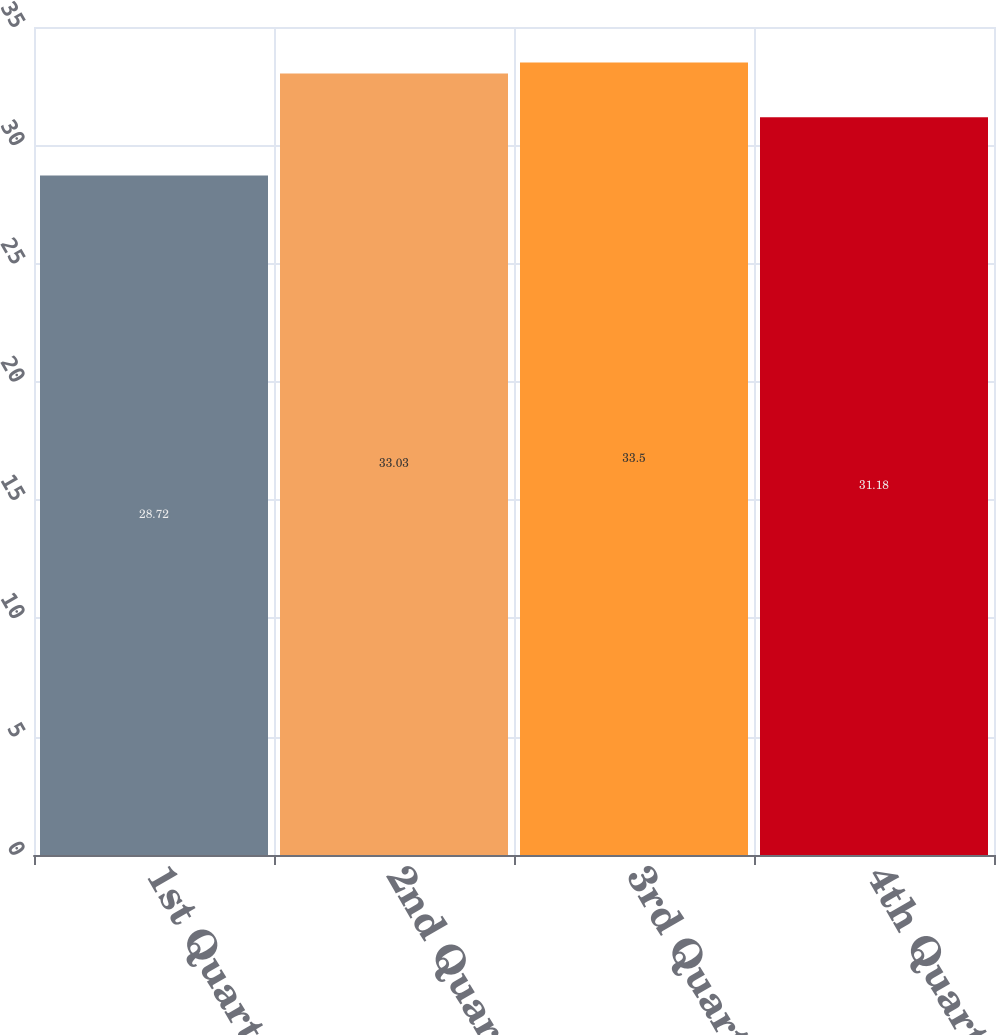<chart> <loc_0><loc_0><loc_500><loc_500><bar_chart><fcel>1st Quarter<fcel>2nd Quarter<fcel>3rd Quarter<fcel>4th Quarter<nl><fcel>28.72<fcel>33.03<fcel>33.5<fcel>31.18<nl></chart> 